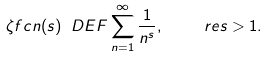Convert formula to latex. <formula><loc_0><loc_0><loc_500><loc_500>\zeta f c n ( s ) \ D E F \sum _ { n = 1 } ^ { \infty } \frac { 1 } { n ^ { s } } , \quad \ r e s > 1 .</formula> 